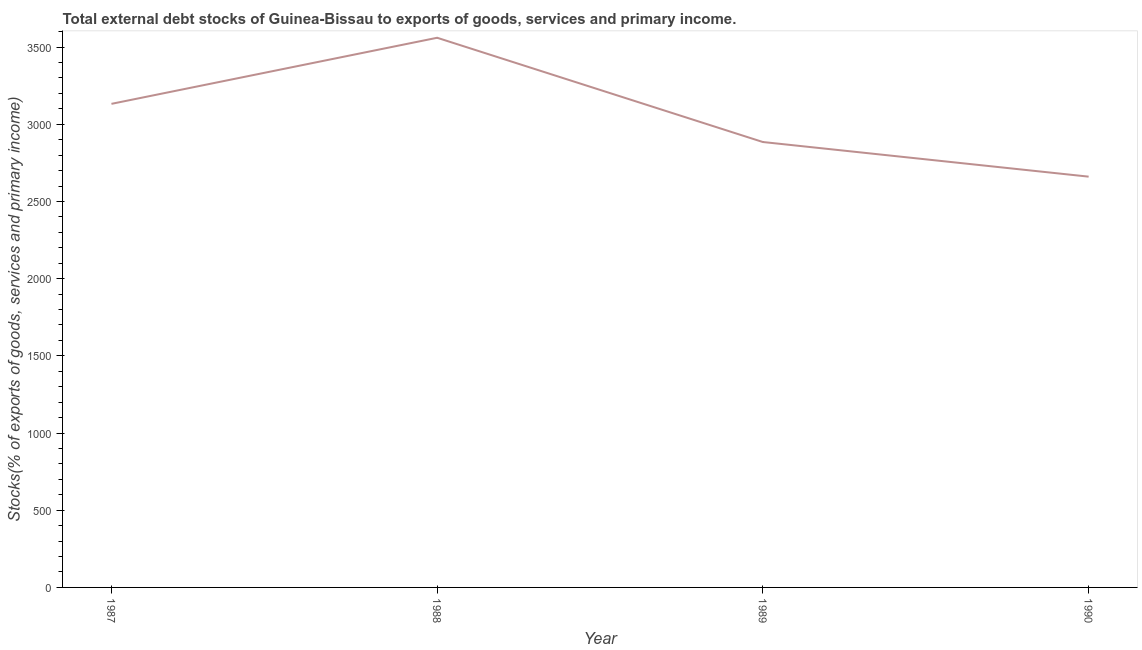What is the external debt stocks in 1989?
Your response must be concise. 2885.18. Across all years, what is the maximum external debt stocks?
Make the answer very short. 3560.54. Across all years, what is the minimum external debt stocks?
Offer a very short reply. 2660.92. In which year was the external debt stocks minimum?
Your answer should be compact. 1990. What is the sum of the external debt stocks?
Provide a succinct answer. 1.22e+04. What is the difference between the external debt stocks in 1988 and 1990?
Offer a very short reply. 899.63. What is the average external debt stocks per year?
Keep it short and to the point. 3059.77. What is the median external debt stocks?
Your answer should be compact. 3008.82. What is the ratio of the external debt stocks in 1988 to that in 1989?
Keep it short and to the point. 1.23. Is the difference between the external debt stocks in 1987 and 1990 greater than the difference between any two years?
Make the answer very short. No. What is the difference between the highest and the second highest external debt stocks?
Your answer should be very brief. 428.09. Is the sum of the external debt stocks in 1989 and 1990 greater than the maximum external debt stocks across all years?
Keep it short and to the point. Yes. What is the difference between the highest and the lowest external debt stocks?
Offer a terse response. 899.63. Does the external debt stocks monotonically increase over the years?
Make the answer very short. No. How many lines are there?
Your answer should be compact. 1. What is the difference between two consecutive major ticks on the Y-axis?
Provide a short and direct response. 500. Does the graph contain grids?
Your answer should be compact. No. What is the title of the graph?
Ensure brevity in your answer.  Total external debt stocks of Guinea-Bissau to exports of goods, services and primary income. What is the label or title of the X-axis?
Offer a terse response. Year. What is the label or title of the Y-axis?
Your answer should be very brief. Stocks(% of exports of goods, services and primary income). What is the Stocks(% of exports of goods, services and primary income) of 1987?
Offer a terse response. 3132.45. What is the Stocks(% of exports of goods, services and primary income) of 1988?
Offer a very short reply. 3560.54. What is the Stocks(% of exports of goods, services and primary income) in 1989?
Make the answer very short. 2885.18. What is the Stocks(% of exports of goods, services and primary income) of 1990?
Your answer should be very brief. 2660.92. What is the difference between the Stocks(% of exports of goods, services and primary income) in 1987 and 1988?
Make the answer very short. -428.09. What is the difference between the Stocks(% of exports of goods, services and primary income) in 1987 and 1989?
Give a very brief answer. 247.28. What is the difference between the Stocks(% of exports of goods, services and primary income) in 1987 and 1990?
Offer a terse response. 471.54. What is the difference between the Stocks(% of exports of goods, services and primary income) in 1988 and 1989?
Make the answer very short. 675.36. What is the difference between the Stocks(% of exports of goods, services and primary income) in 1988 and 1990?
Provide a succinct answer. 899.63. What is the difference between the Stocks(% of exports of goods, services and primary income) in 1989 and 1990?
Give a very brief answer. 224.26. What is the ratio of the Stocks(% of exports of goods, services and primary income) in 1987 to that in 1989?
Provide a succinct answer. 1.09. What is the ratio of the Stocks(% of exports of goods, services and primary income) in 1987 to that in 1990?
Offer a terse response. 1.18. What is the ratio of the Stocks(% of exports of goods, services and primary income) in 1988 to that in 1989?
Provide a short and direct response. 1.23. What is the ratio of the Stocks(% of exports of goods, services and primary income) in 1988 to that in 1990?
Provide a succinct answer. 1.34. What is the ratio of the Stocks(% of exports of goods, services and primary income) in 1989 to that in 1990?
Make the answer very short. 1.08. 